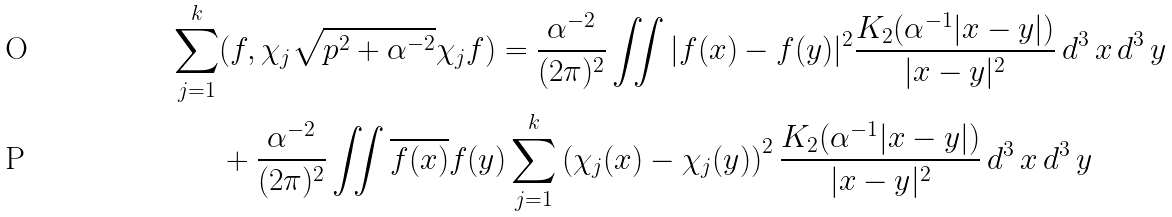<formula> <loc_0><loc_0><loc_500><loc_500>\sum _ { j = 1 } ^ { k } & ( f , \chi _ { j } \sqrt { p ^ { 2 } + \alpha ^ { - 2 } } \chi _ { j } f ) = \frac { \alpha ^ { - 2 } } { ( 2 \pi ) ^ { 2 } } \iint | f ( x ) - f ( y ) | ^ { 2 } \frac { K _ { 2 } ( \alpha ^ { - 1 } | x - y | ) } { | x - y | ^ { 2 } } \, d ^ { 3 } \, x \, d ^ { 3 } \, y \\ & + \frac { \alpha ^ { - 2 } } { ( 2 \pi ) ^ { 2 } } \iint \overline { f ( x ) } f ( y ) \sum _ { j = 1 } ^ { k } \left ( \chi _ { j } ( x ) - \chi _ { j } ( y ) \right ) ^ { 2 } \frac { K _ { 2 } ( \alpha ^ { - 1 } | x - y | ) } { | x - y | ^ { 2 } } \, d ^ { 3 } \, x \, d ^ { 3 } \, y</formula> 